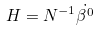Convert formula to latex. <formula><loc_0><loc_0><loc_500><loc_500>H = { N ^ { - 1 } } { \dot { { \beta } ^ { 0 } } }</formula> 